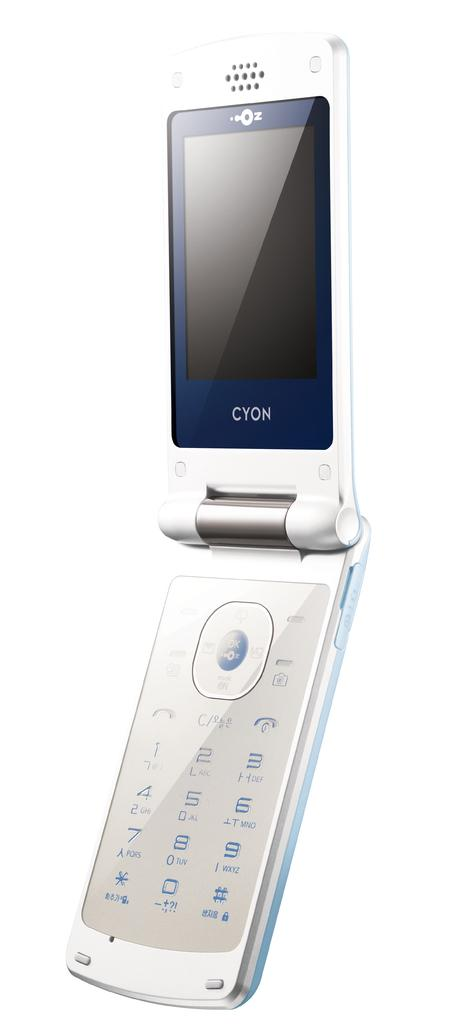<image>
Give a short and clear explanation of the subsequent image. A white Cyon flip phone against a white back drop. 